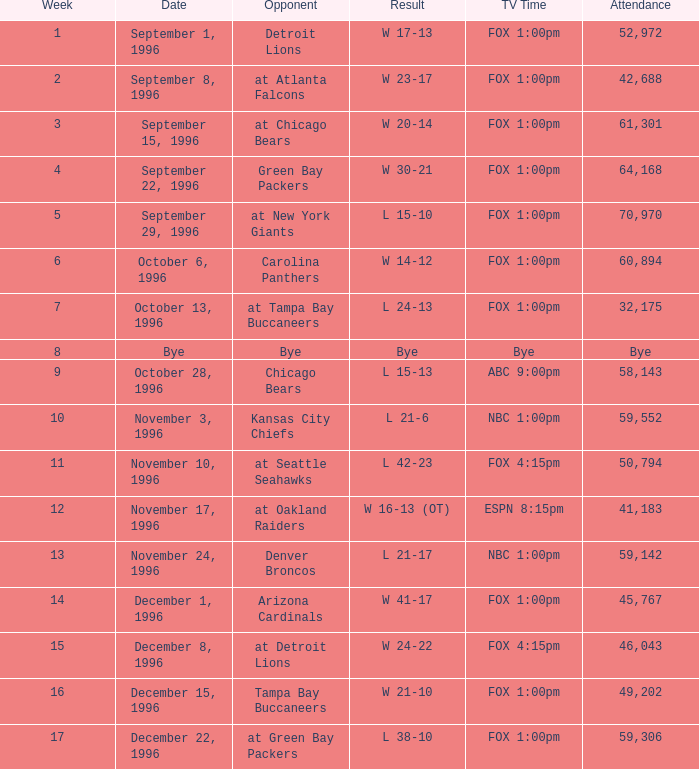Tell me the lowest week for attendance of 60,894 6.0. 